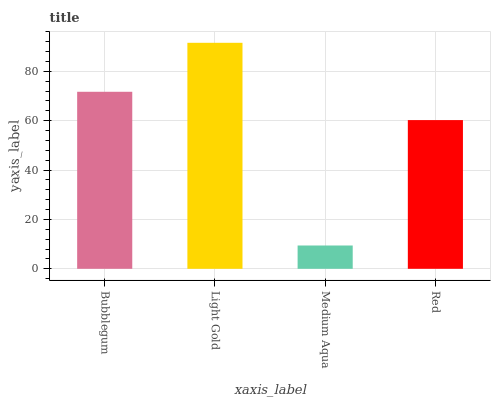Is Medium Aqua the minimum?
Answer yes or no. Yes. Is Light Gold the maximum?
Answer yes or no. Yes. Is Light Gold the minimum?
Answer yes or no. No. Is Medium Aqua the maximum?
Answer yes or no. No. Is Light Gold greater than Medium Aqua?
Answer yes or no. Yes. Is Medium Aqua less than Light Gold?
Answer yes or no. Yes. Is Medium Aqua greater than Light Gold?
Answer yes or no. No. Is Light Gold less than Medium Aqua?
Answer yes or no. No. Is Bubblegum the high median?
Answer yes or no. Yes. Is Red the low median?
Answer yes or no. Yes. Is Light Gold the high median?
Answer yes or no. No. Is Medium Aqua the low median?
Answer yes or no. No. 